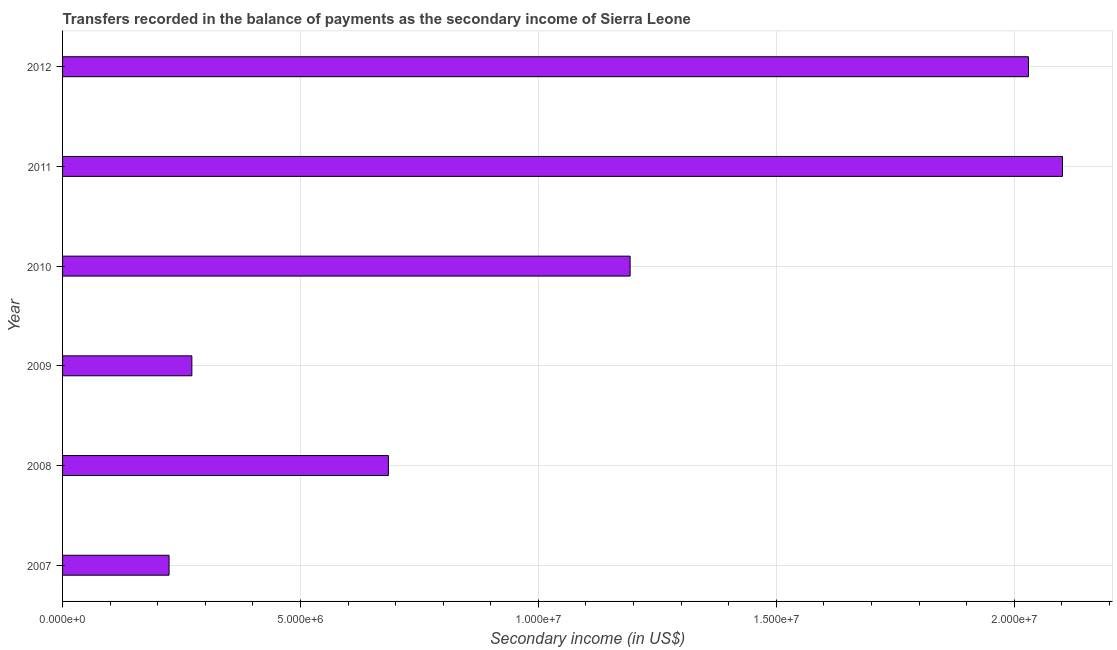Does the graph contain any zero values?
Ensure brevity in your answer.  No. What is the title of the graph?
Your response must be concise. Transfers recorded in the balance of payments as the secondary income of Sierra Leone. What is the label or title of the X-axis?
Your answer should be very brief. Secondary income (in US$). What is the label or title of the Y-axis?
Make the answer very short. Year. What is the amount of secondary income in 2009?
Offer a very short reply. 2.72e+06. Across all years, what is the maximum amount of secondary income?
Make the answer very short. 2.10e+07. Across all years, what is the minimum amount of secondary income?
Provide a succinct answer. 2.24e+06. What is the sum of the amount of secondary income?
Your response must be concise. 6.50e+07. What is the difference between the amount of secondary income in 2010 and 2012?
Make the answer very short. -8.37e+06. What is the average amount of secondary income per year?
Keep it short and to the point. 1.08e+07. What is the median amount of secondary income?
Offer a very short reply. 9.39e+06. Do a majority of the years between 2008 and 2011 (inclusive) have amount of secondary income greater than 8000000 US$?
Give a very brief answer. No. What is the ratio of the amount of secondary income in 2009 to that in 2012?
Your response must be concise. 0.13. Is the amount of secondary income in 2011 less than that in 2012?
Your response must be concise. No. What is the difference between the highest and the second highest amount of secondary income?
Provide a short and direct response. 7.15e+05. Is the sum of the amount of secondary income in 2008 and 2012 greater than the maximum amount of secondary income across all years?
Offer a very short reply. Yes. What is the difference between the highest and the lowest amount of secondary income?
Make the answer very short. 1.88e+07. How many bars are there?
Provide a succinct answer. 6. Are all the bars in the graph horizontal?
Your response must be concise. Yes. How many years are there in the graph?
Your response must be concise. 6. What is the Secondary income (in US$) in 2007?
Offer a terse response. 2.24e+06. What is the Secondary income (in US$) of 2008?
Your answer should be compact. 6.85e+06. What is the Secondary income (in US$) in 2009?
Provide a succinct answer. 2.72e+06. What is the Secondary income (in US$) in 2010?
Offer a very short reply. 1.19e+07. What is the Secondary income (in US$) of 2011?
Make the answer very short. 2.10e+07. What is the Secondary income (in US$) in 2012?
Your response must be concise. 2.03e+07. What is the difference between the Secondary income (in US$) in 2007 and 2008?
Offer a terse response. -4.61e+06. What is the difference between the Secondary income (in US$) in 2007 and 2009?
Ensure brevity in your answer.  -4.79e+05. What is the difference between the Secondary income (in US$) in 2007 and 2010?
Keep it short and to the point. -9.69e+06. What is the difference between the Secondary income (in US$) in 2007 and 2011?
Your answer should be compact. -1.88e+07. What is the difference between the Secondary income (in US$) in 2007 and 2012?
Offer a very short reply. -1.81e+07. What is the difference between the Secondary income (in US$) in 2008 and 2009?
Make the answer very short. 4.13e+06. What is the difference between the Secondary income (in US$) in 2008 and 2010?
Ensure brevity in your answer.  -5.08e+06. What is the difference between the Secondary income (in US$) in 2008 and 2011?
Make the answer very short. -1.42e+07. What is the difference between the Secondary income (in US$) in 2008 and 2012?
Make the answer very short. -1.35e+07. What is the difference between the Secondary income (in US$) in 2009 and 2010?
Provide a succinct answer. -9.21e+06. What is the difference between the Secondary income (in US$) in 2009 and 2011?
Offer a terse response. -1.83e+07. What is the difference between the Secondary income (in US$) in 2009 and 2012?
Give a very brief answer. -1.76e+07. What is the difference between the Secondary income (in US$) in 2010 and 2011?
Provide a succinct answer. -9.09e+06. What is the difference between the Secondary income (in US$) in 2010 and 2012?
Your answer should be very brief. -8.37e+06. What is the difference between the Secondary income (in US$) in 2011 and 2012?
Make the answer very short. 7.15e+05. What is the ratio of the Secondary income (in US$) in 2007 to that in 2008?
Provide a succinct answer. 0.33. What is the ratio of the Secondary income (in US$) in 2007 to that in 2009?
Give a very brief answer. 0.82. What is the ratio of the Secondary income (in US$) in 2007 to that in 2010?
Keep it short and to the point. 0.19. What is the ratio of the Secondary income (in US$) in 2007 to that in 2011?
Your answer should be compact. 0.11. What is the ratio of the Secondary income (in US$) in 2007 to that in 2012?
Your answer should be very brief. 0.11. What is the ratio of the Secondary income (in US$) in 2008 to that in 2009?
Make the answer very short. 2.52. What is the ratio of the Secondary income (in US$) in 2008 to that in 2010?
Ensure brevity in your answer.  0.57. What is the ratio of the Secondary income (in US$) in 2008 to that in 2011?
Provide a short and direct response. 0.33. What is the ratio of the Secondary income (in US$) in 2008 to that in 2012?
Your answer should be very brief. 0.34. What is the ratio of the Secondary income (in US$) in 2009 to that in 2010?
Your answer should be very brief. 0.23. What is the ratio of the Secondary income (in US$) in 2009 to that in 2011?
Provide a short and direct response. 0.13. What is the ratio of the Secondary income (in US$) in 2009 to that in 2012?
Keep it short and to the point. 0.13. What is the ratio of the Secondary income (in US$) in 2010 to that in 2011?
Give a very brief answer. 0.57. What is the ratio of the Secondary income (in US$) in 2010 to that in 2012?
Offer a terse response. 0.59. What is the ratio of the Secondary income (in US$) in 2011 to that in 2012?
Offer a very short reply. 1.03. 